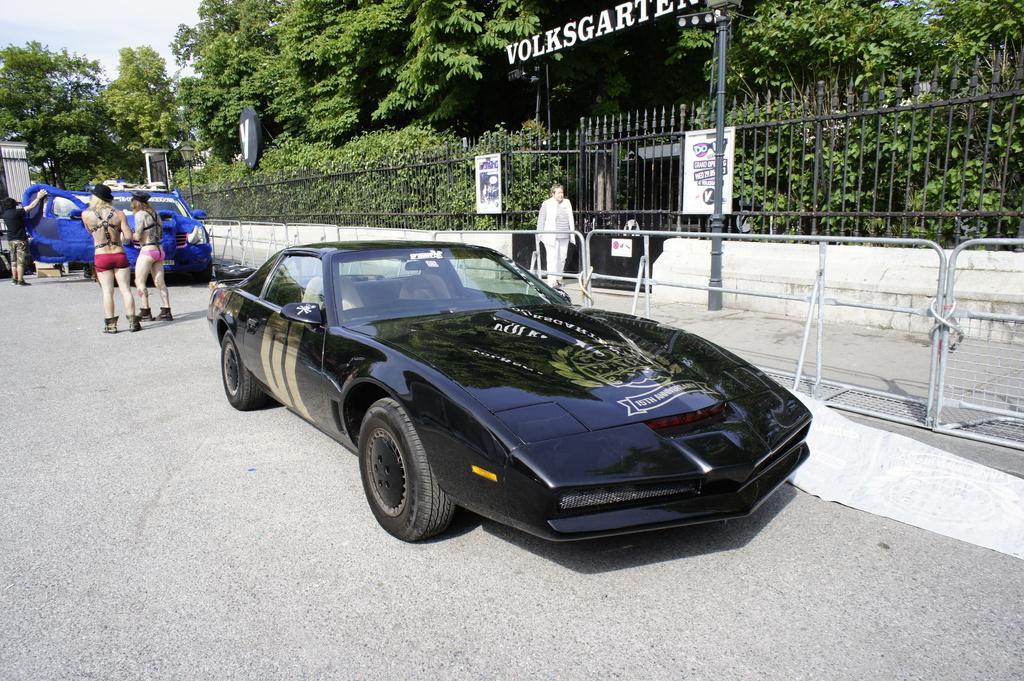Can you describe this image briefly? In this picture I can see there are two cars and there are two women standing and there is a man walking on the walkway and in the backdrop there are trees and the sky is clear. 